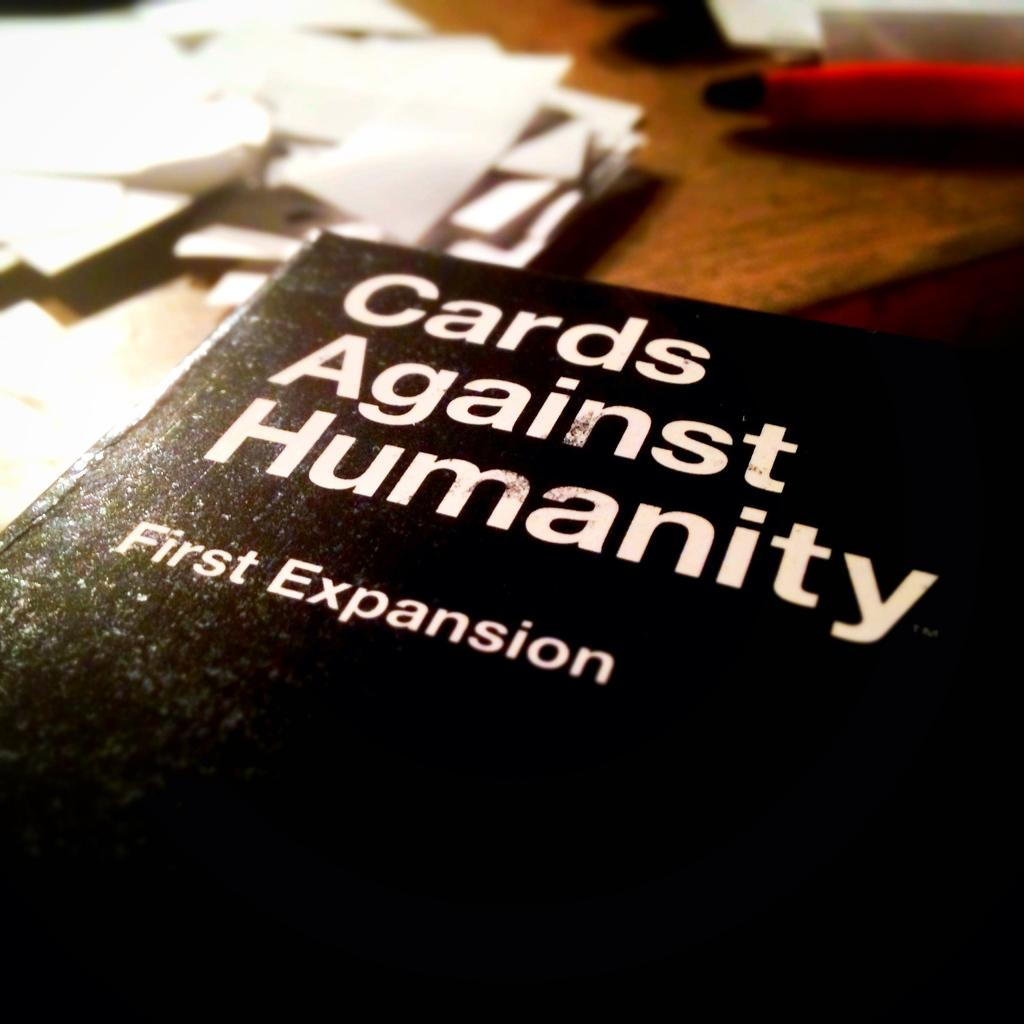What object is placed on the table in the image? There is a book on the table in the image. What else can be seen on the table in the image? There are papers on the table in the image. Where was the image taken? The image was taken in a room. What type of credit can be seen on the tongue of the person in the image? There is no person present in the image, and therefore no tongue or credit can be observed. 